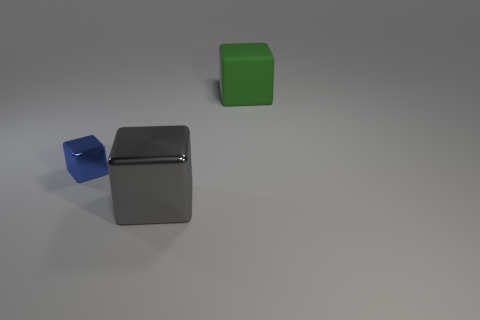Is there any other thing that is the same material as the large green thing?
Keep it short and to the point. No. The thing that is both behind the large gray thing and on the right side of the tiny blue metal block is what color?
Give a very brief answer. Green. How many other things are there of the same size as the green cube?
Make the answer very short. 1. Do the blue metallic thing and the object to the right of the gray metal cube have the same size?
Offer a terse response. No. There is a thing that is the same size as the green matte cube; what is its color?
Provide a short and direct response. Gray. The blue metallic object is what size?
Give a very brief answer. Small. Are the block on the left side of the large gray block and the big gray cube made of the same material?
Give a very brief answer. Yes. Is the rubber thing the same shape as the big shiny thing?
Your answer should be compact. Yes. There is a metallic object behind the large gray thing; is it the same shape as the big thing on the right side of the big metallic object?
Your answer should be compact. Yes. Is there a tiny red ball made of the same material as the blue block?
Ensure brevity in your answer.  No. 